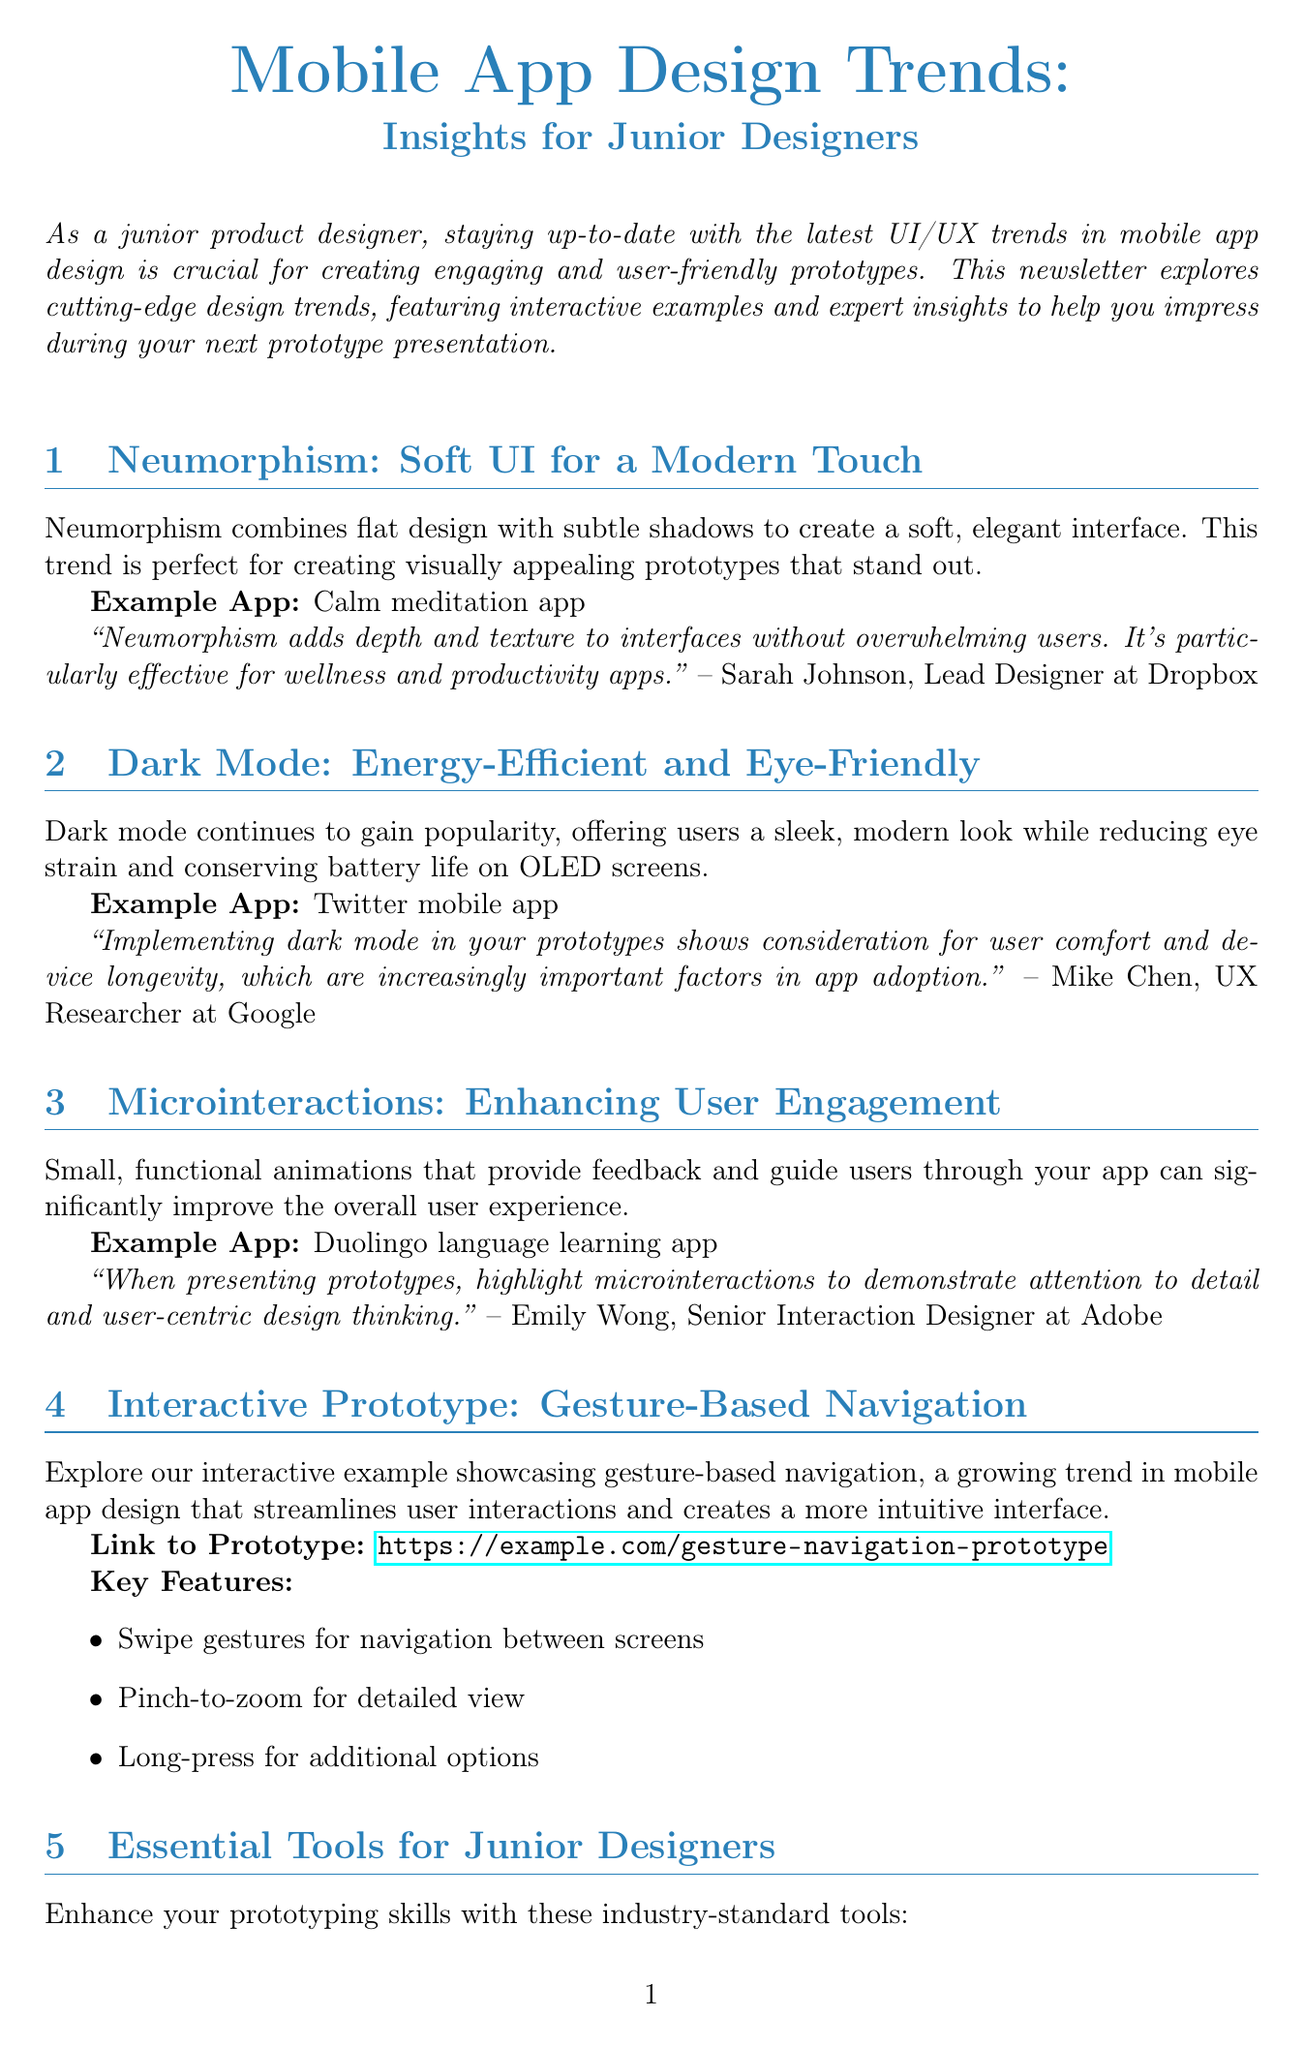What is the title of the newsletter? The title of the newsletter is prominently displayed at the beginning, highlighting the subject matter for junior designers.
Answer: Mobile App Design Trends: Insights for Junior Designers Who provided insights on Neumorphism? The document includes expert insights from various professionals, indicating their names and affiliations.
Answer: Sarah Johnson What is an example app that uses Dark Mode? The newsletter provides specific applications that exemplify each design trend discussed, including their names.
Answer: Twitter mobile app What is a key feature of the interactive prototype? Important characteristics of the interactive example are listed to showcase its functionality.
Answer: Swipe gestures for navigation between screens What tool is mentioned for collaborative design? A list of essential tools for junior designers is provided in the newsletter, specifying their functions.
Answer: Figma How many design trends are discussed in the newsletter? The total count of design trends discussed is presented in the sections; summing up both trends and examples provides the total.
Answer: Three Who is the expert for Microinteractions? Identifying the individual associated with expert insights on Microinteractions provides clarity on the information source in the document.
Answer: Emily Wong What is the link to the interactive prototype? The newsletter contains a specific link to an interactive example that complements the discussed trends.
Answer: https://example.com/gesture-navigation-prototype 